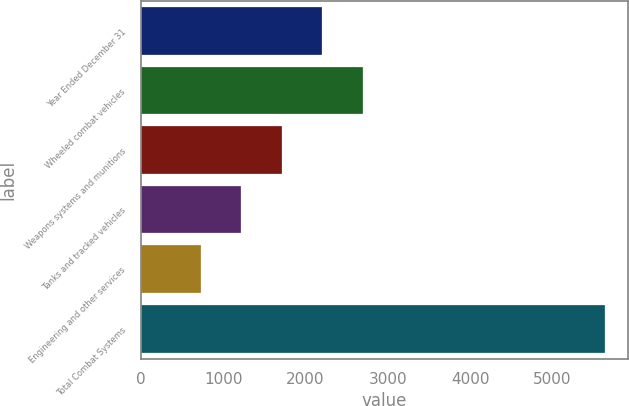<chart> <loc_0><loc_0><loc_500><loc_500><bar_chart><fcel>Year Ended December 31<fcel>Wheeled combat vehicles<fcel>Weapons systems and munitions<fcel>Tanks and tracked vehicles<fcel>Engineering and other services<fcel>Total Combat Systems<nl><fcel>2202.3<fcel>2693.4<fcel>1711.2<fcel>1220.1<fcel>729<fcel>5640<nl></chart> 